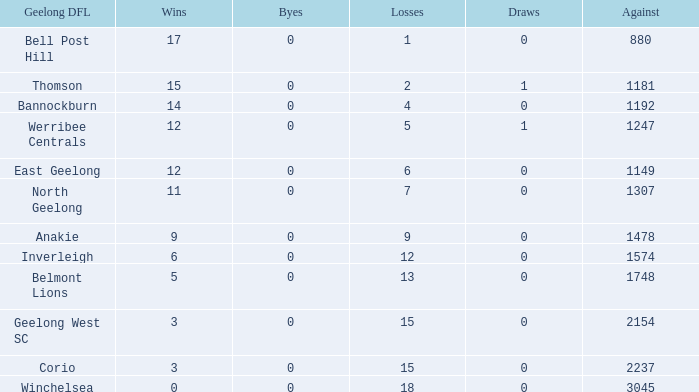What is the lowest number of wins where the losses are more than 12 and the draws are less than 0? None. 